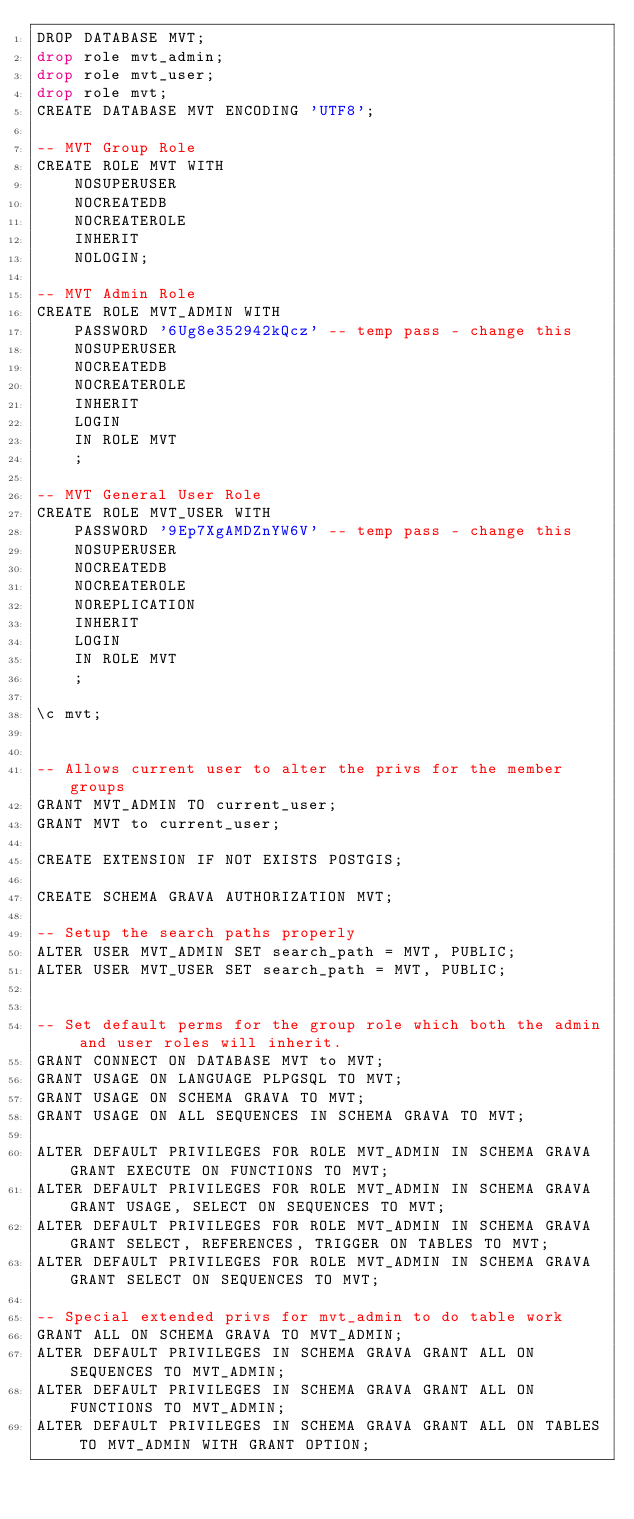<code> <loc_0><loc_0><loc_500><loc_500><_SQL_>DROP DATABASE MVT;
drop role mvt_admin;
drop role mvt_user;
drop role mvt;
CREATE DATABASE MVT ENCODING 'UTF8';

-- MVT Group Role
CREATE ROLE MVT WITH 
    NOSUPERUSER
    NOCREATEDB
    NOCREATEROLE
    INHERIT
    NOLOGIN;

-- MVT Admin Role
CREATE ROLE MVT_ADMIN WITH
    PASSWORD '6Ug8e352942kQcz' -- temp pass - change this
    NOSUPERUSER
    NOCREATEDB
    NOCREATEROLE
    INHERIT
    LOGIN
    IN ROLE MVT
    ;

-- MVT General User Role
CREATE ROLE MVT_USER WITH
    PASSWORD '9Ep7XgAMDZnYW6V' -- temp pass - change this
    NOSUPERUSER
    NOCREATEDB
    NOCREATEROLE
    NOREPLICATION
    INHERIT
    LOGIN
    IN ROLE MVT
    ;

\c mvt;


-- Allows current user to alter the privs for the member groups
GRANT MVT_ADMIN TO current_user;
GRANT MVT to current_user;

CREATE EXTENSION IF NOT EXISTS POSTGIS;

CREATE SCHEMA GRAVA AUTHORIZATION MVT;

-- Setup the search paths properly
ALTER USER MVT_ADMIN SET search_path = MVT, PUBLIC;
ALTER USER MVT_USER SET search_path = MVT, PUBLIC;


-- Set default perms for the group role which both the admin and user roles will inherit.
GRANT CONNECT ON DATABASE MVT to MVT;
GRANT USAGE ON LANGUAGE PLPGSQL TO MVT;
GRANT USAGE ON SCHEMA GRAVA TO MVT;
GRANT USAGE ON ALL SEQUENCES IN SCHEMA GRAVA TO MVT;

ALTER DEFAULT PRIVILEGES FOR ROLE MVT_ADMIN IN SCHEMA GRAVA GRANT EXECUTE ON FUNCTIONS TO MVT;
ALTER DEFAULT PRIVILEGES FOR ROLE MVT_ADMIN IN SCHEMA GRAVA GRANT USAGE, SELECT ON SEQUENCES TO MVT;
ALTER DEFAULT PRIVILEGES FOR ROLE MVT_ADMIN IN SCHEMA GRAVA GRANT SELECT, REFERENCES, TRIGGER ON TABLES TO MVT;
ALTER DEFAULT PRIVILEGES FOR ROLE MVT_ADMIN IN SCHEMA GRAVA GRANT SELECT ON SEQUENCES TO MVT;

-- Special extended privs for mvt_admin to do table work
GRANT ALL ON SCHEMA GRAVA TO MVT_ADMIN;
ALTER DEFAULT PRIVILEGES IN SCHEMA GRAVA GRANT ALL ON SEQUENCES TO MVT_ADMIN;
ALTER DEFAULT PRIVILEGES IN SCHEMA GRAVA GRANT ALL ON FUNCTIONS TO MVT_ADMIN;
ALTER DEFAULT PRIVILEGES IN SCHEMA GRAVA GRANT ALL ON TABLES TO MVT_ADMIN WITH GRANT OPTION;</code> 